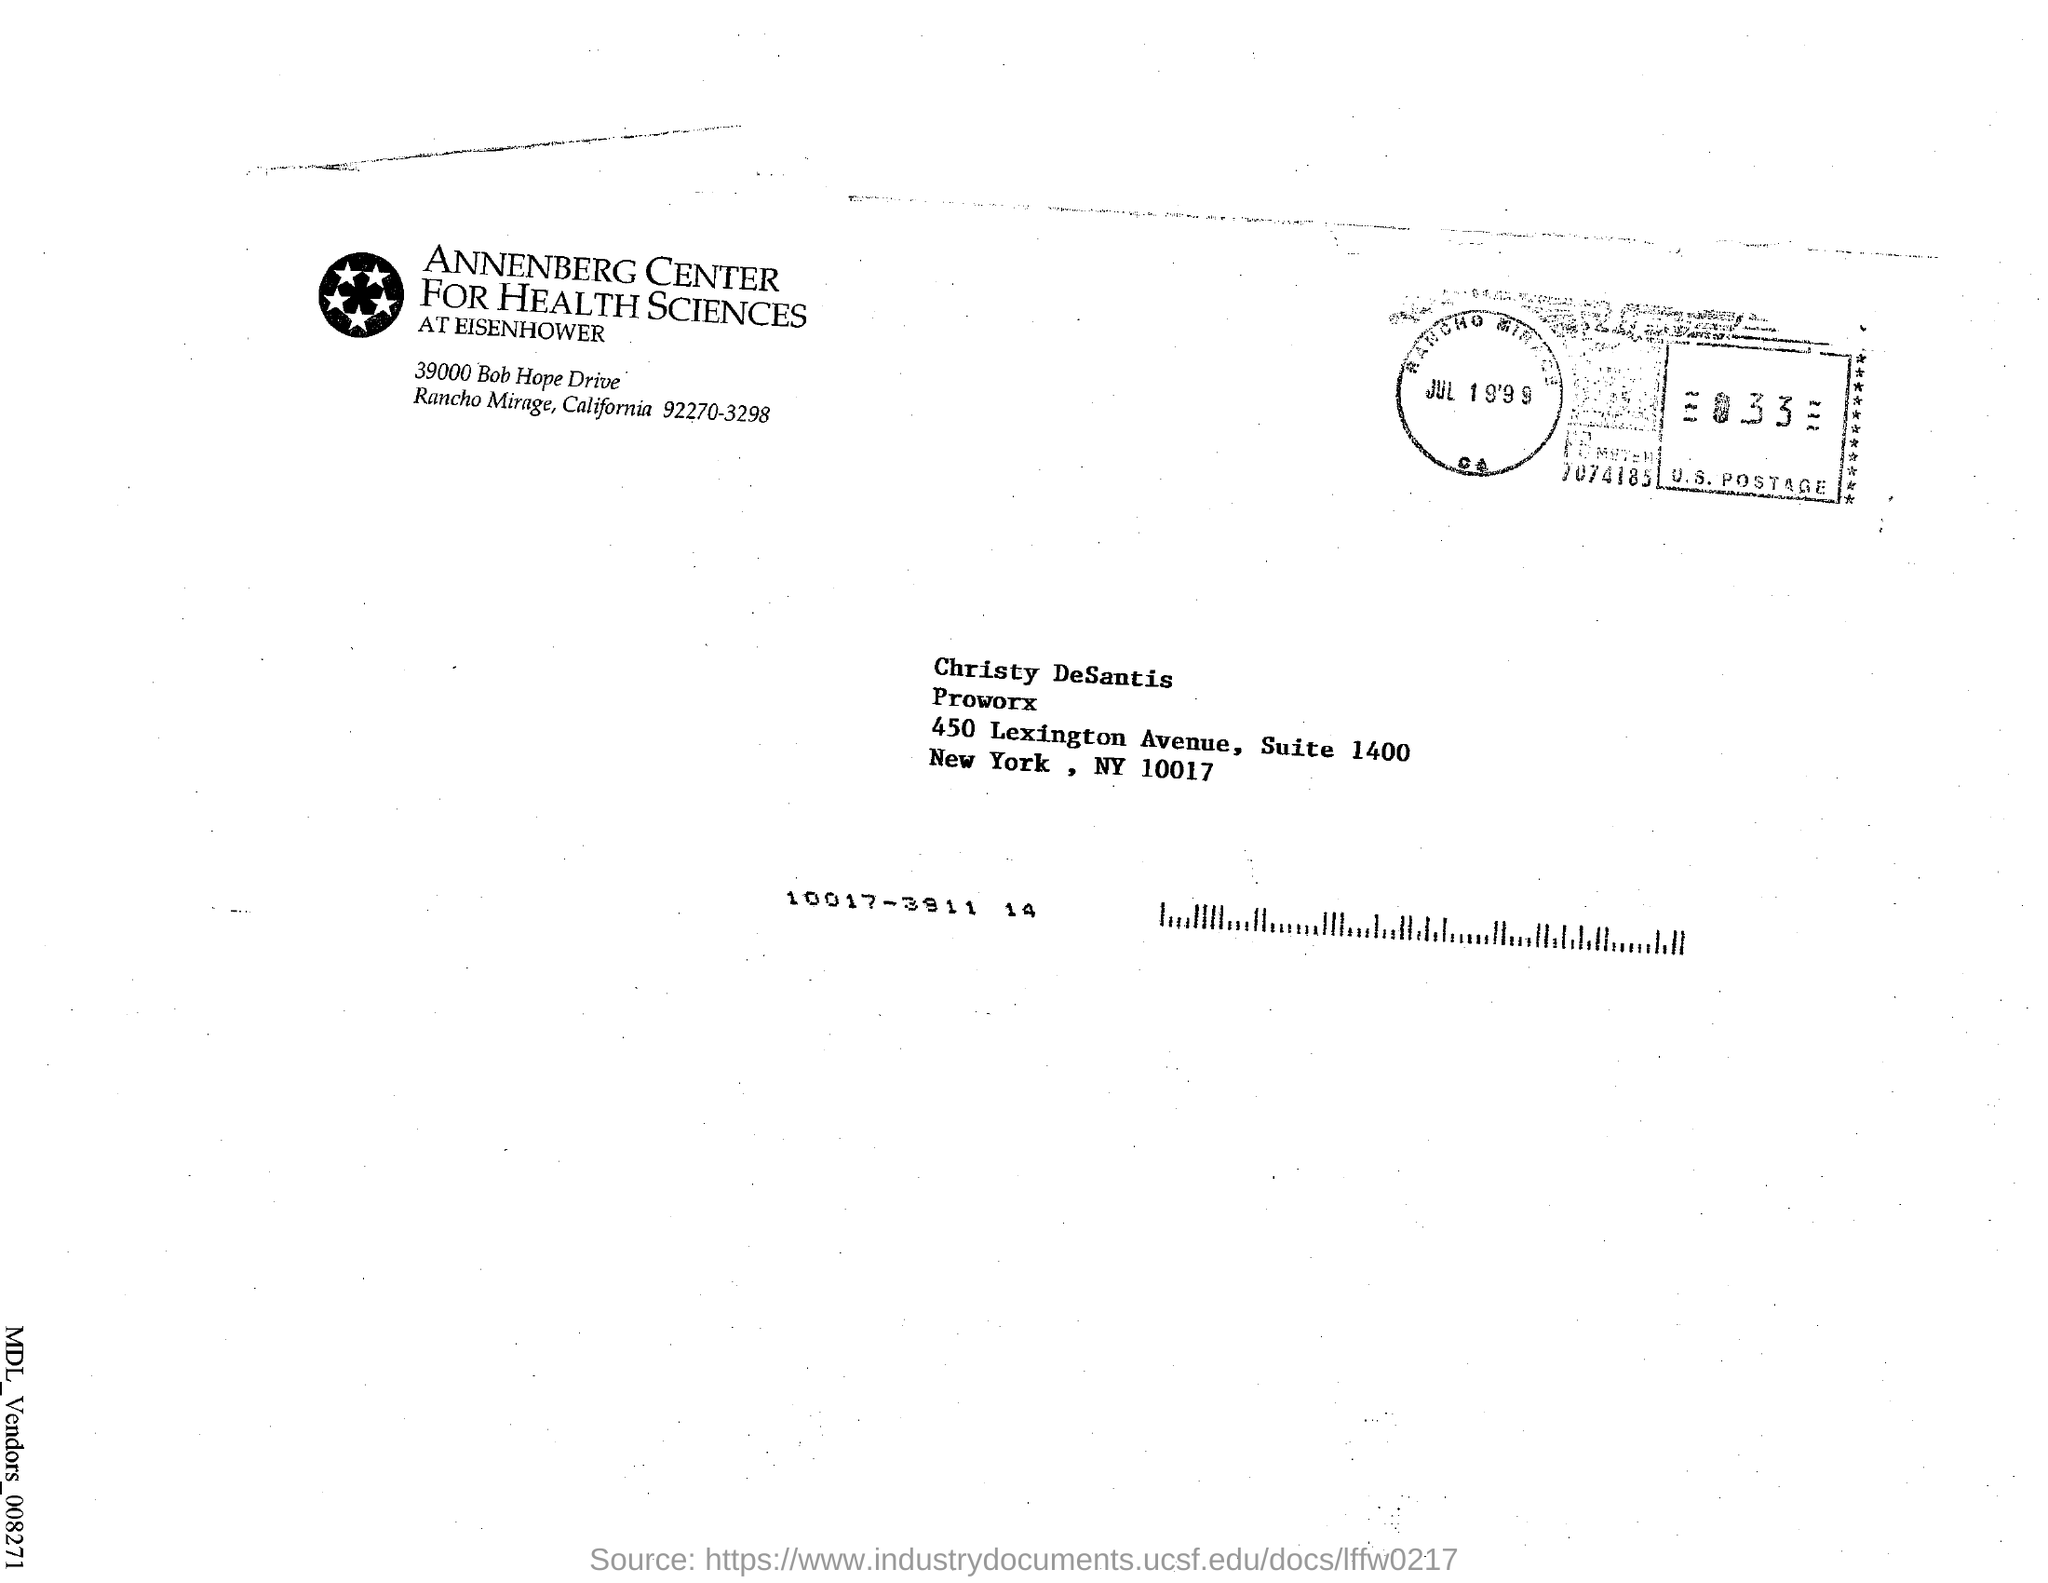What is the name given in the address?
Give a very brief answer. Christy DeSantis. What is the date mentioned in the U. S. Postage stamp?
Your answer should be very brief. Jul 19'99. 